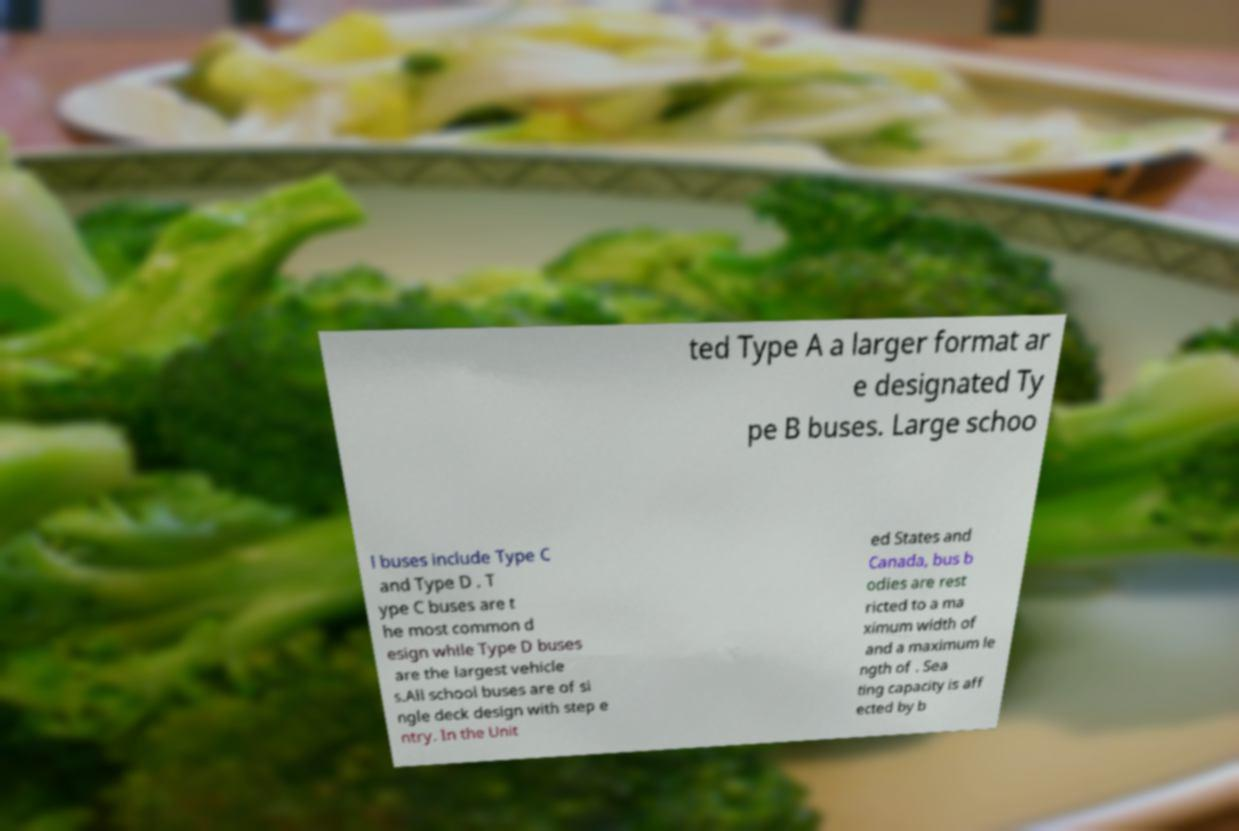Can you read and provide the text displayed in the image?This photo seems to have some interesting text. Can you extract and type it out for me? ted Type A a larger format ar e designated Ty pe B buses. Large schoo l buses include Type C and Type D . T ype C buses are t he most common d esign while Type D buses are the largest vehicle s.All school buses are of si ngle deck design with step e ntry. In the Unit ed States and Canada, bus b odies are rest ricted to a ma ximum width of and a maximum le ngth of . Sea ting capacity is aff ected by b 